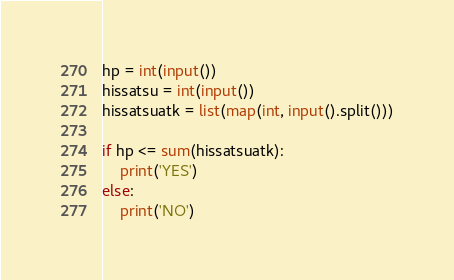<code> <loc_0><loc_0><loc_500><loc_500><_Python_>hp = int(input())
hissatsu = int(input())
hissatsuatk = list(map(int, input().split()))

if hp <= sum(hissatsuatk):
    print('YES')
else:
    print('NO')
</code> 